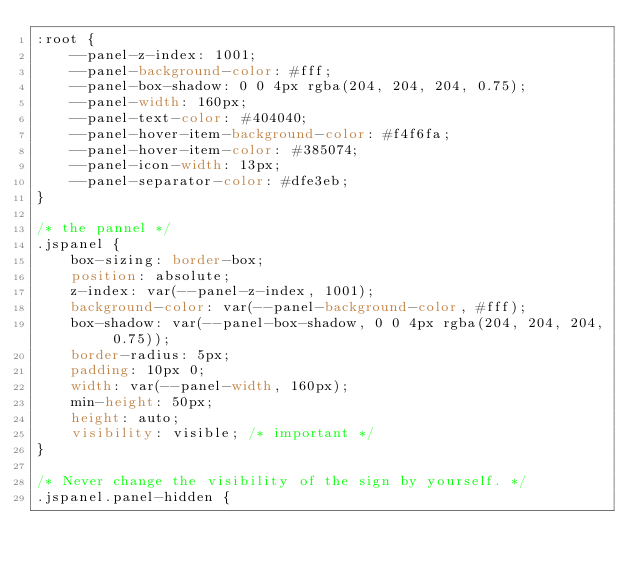<code> <loc_0><loc_0><loc_500><loc_500><_CSS_>:root {
    --panel-z-index: 1001;
    --panel-background-color: #fff;
    --panel-box-shadow: 0 0 4px rgba(204, 204, 204, 0.75);
    --panel-width: 160px;
    --panel-text-color: #404040;
    --panel-hover-item-background-color: #f4f6fa;
    --panel-hover-item-color: #385074;
    --panel-icon-width: 13px;
    --panel-separator-color: #dfe3eb;
}

/* the pannel */
.jspanel {
    box-sizing: border-box;
    position: absolute;
    z-index: var(--panel-z-index, 1001);
    background-color: var(--panel-background-color, #fff);
    box-shadow: var(--panel-box-shadow, 0 0 4px rgba(204, 204, 204, 0.75));
    border-radius: 5px;
    padding: 10px 0;
    width: var(--panel-width, 160px);
    min-height: 50px;
    height: auto;
    visibility: visible; /* important */
}

/* Never change the visibility of the sign by yourself. */
.jspanel.panel-hidden {</code> 